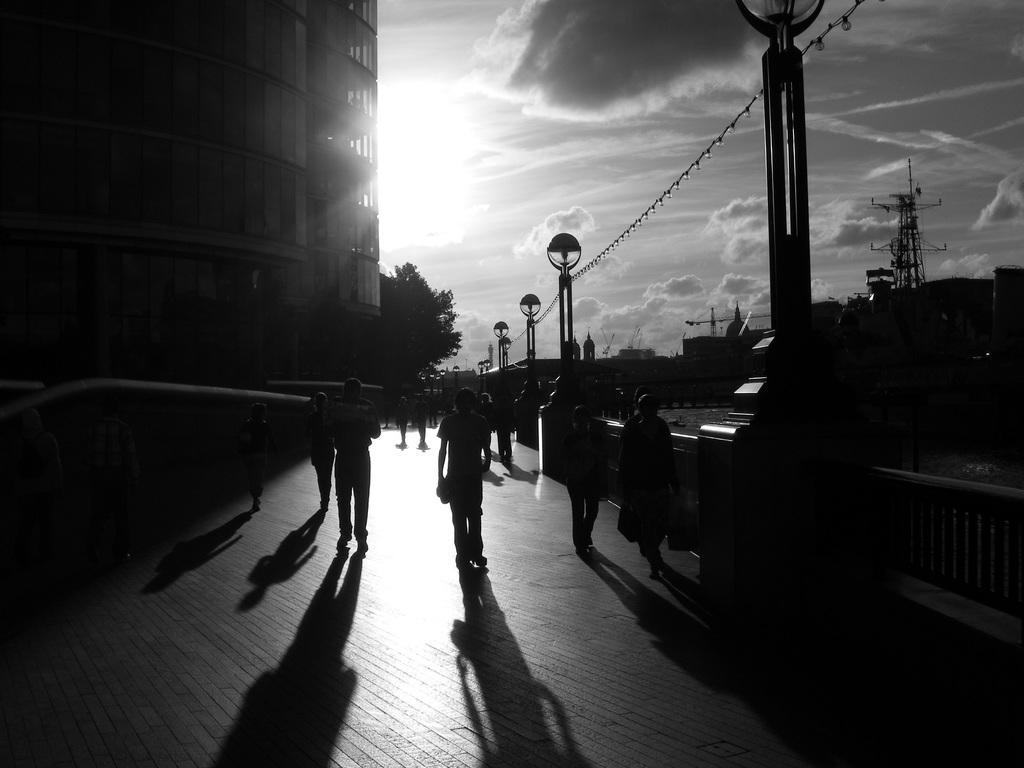In one or two sentences, can you explain what this image depicts? This is a black and white image. We can see groups of people and shadows on the walkway. On the right side of the image, there are street lights and railing. Behind the people, there is a tree and it looks like a bridge. At the top of the image, there is the sky. On the left and right side of the image, there are buildings. 